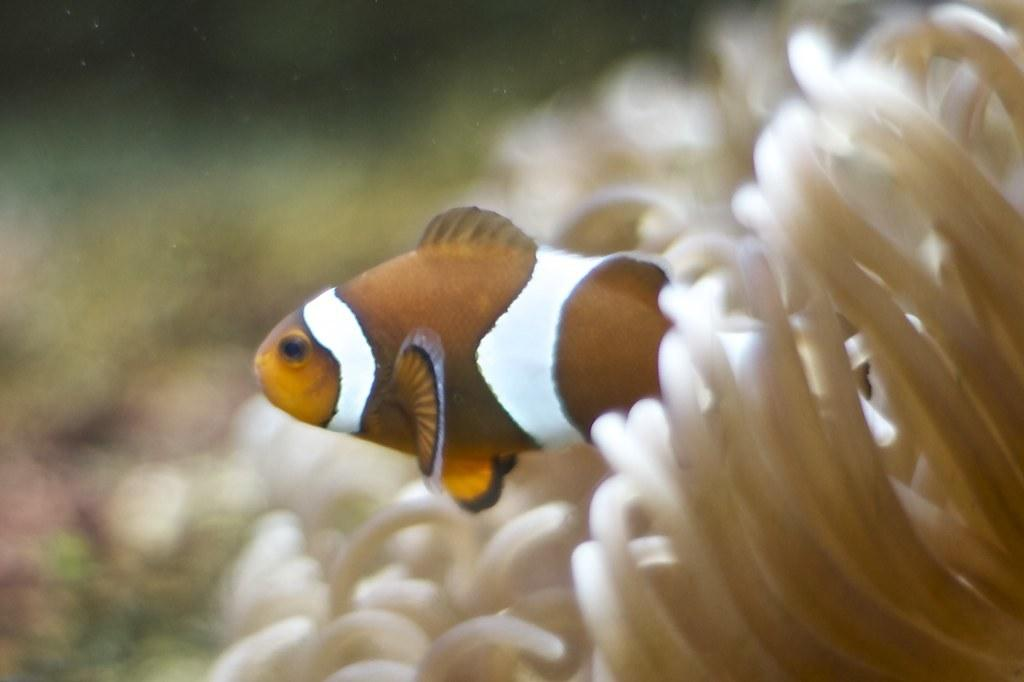What type of animal is in the image? There is a fish in the image. Where is the fish located? The fish is present in the water. What else can be seen in the image besides the fish? There are plants visible in the image. What type of crown is the fish wearing in the image? There is no crown present in the image; the fish is not wearing any accessories. 